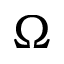Convert formula to latex. <formula><loc_0><loc_0><loc_500><loc_500>\Omega</formula> 